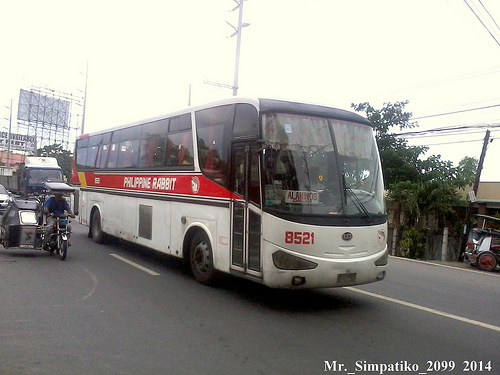<image>
Is the bus behind the motorcycle? No. The bus is not behind the motorcycle. From this viewpoint, the bus appears to be positioned elsewhere in the scene. 